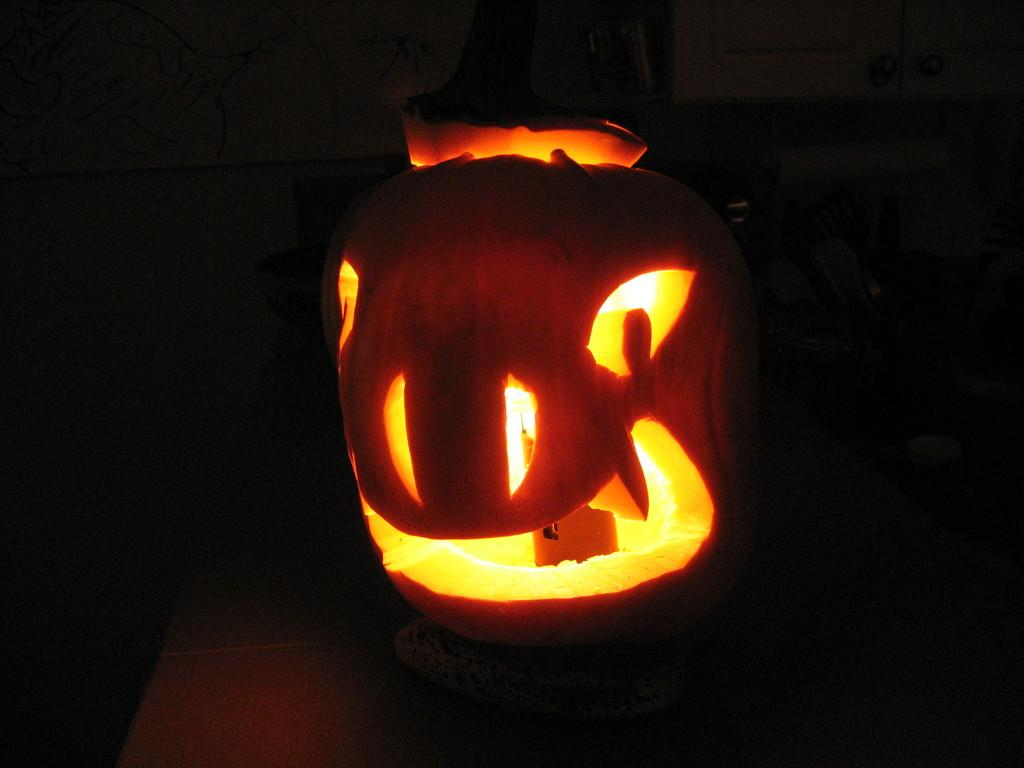What is the main object in the image? There is a pumpkin in the image. What is inside the pumpkin? There is a lamp inside the pumpkin. What type of record can be seen playing on the pumpkin's surface in the image? There is no record or any music-related item present in the image. 